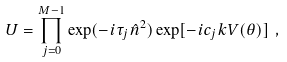<formula> <loc_0><loc_0><loc_500><loc_500>U = \prod _ { j = 0 } ^ { M - 1 } \exp ( - i \tau _ { j } { \hat { n } } ^ { 2 } ) \exp [ - i c _ { j } k V ( \theta ) ] \ ,</formula> 